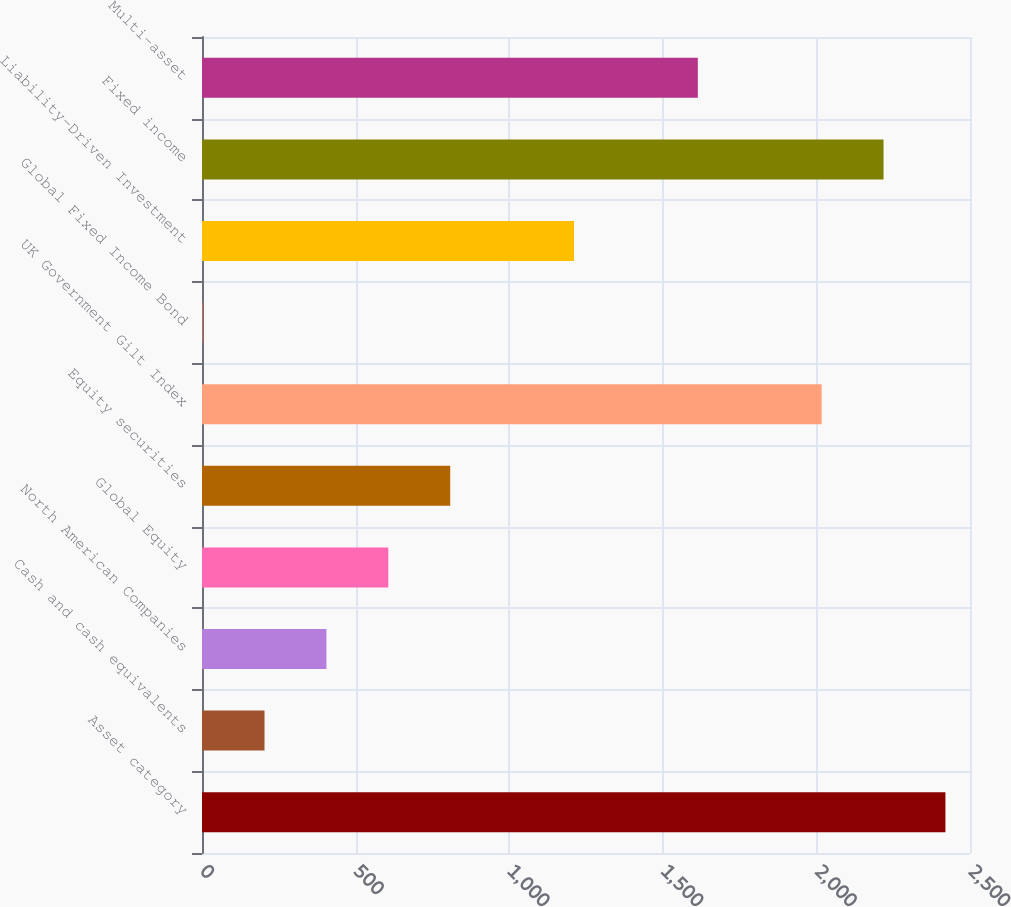Convert chart to OTSL. <chart><loc_0><loc_0><loc_500><loc_500><bar_chart><fcel>Asset category<fcel>Cash and cash equivalents<fcel>North American Companies<fcel>Global Equity<fcel>Equity securities<fcel>UK Government Gilt Index<fcel>Global Fixed Income Bond<fcel>Liability-Driven Investment<fcel>Fixed income<fcel>Multi-asset<nl><fcel>2420<fcel>203.5<fcel>405<fcel>606.5<fcel>808<fcel>2017<fcel>2<fcel>1211<fcel>2218.5<fcel>1614<nl></chart> 